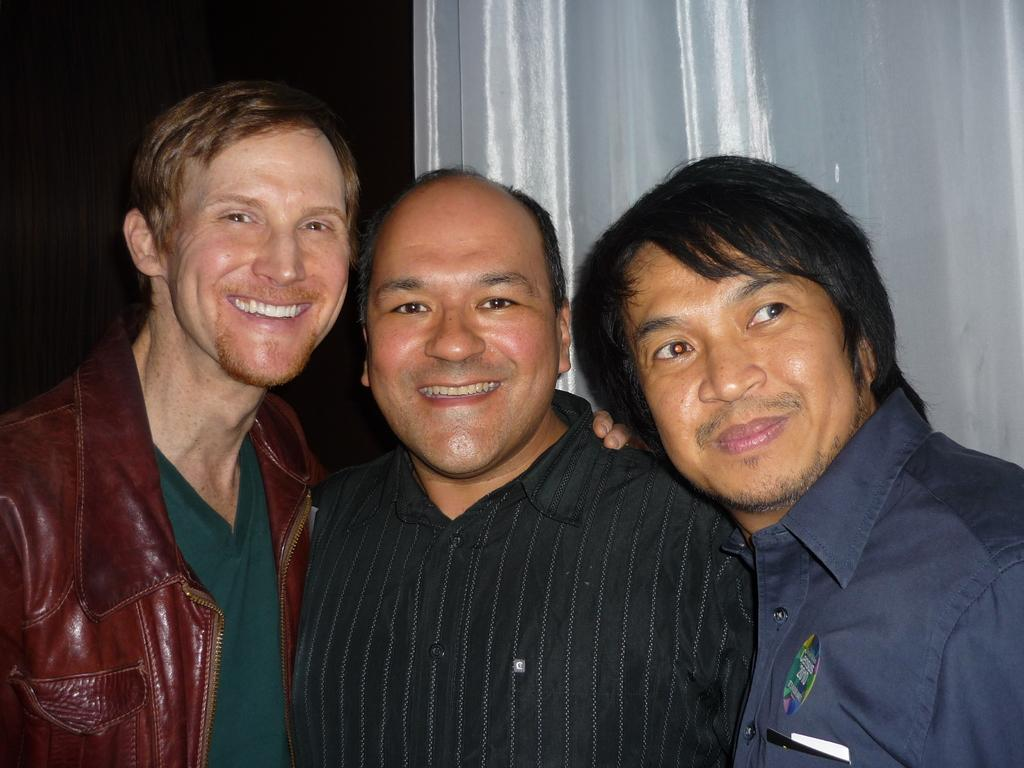How many people are in the image? There are three men in the image. What are the men doing in the image? The men are standing together. What expressions do the men have in the image? A: The men are smiling in the image. What type of clothing is worn by two of the men? Two of the men are wearing shirts. What type of clothing is worn by the man on the left side? The man on the left side is wearing a jacket. What animals can be seen at the zoo in the image? There is no zoo or animals present in the image; it features three men standing together and smiling. 